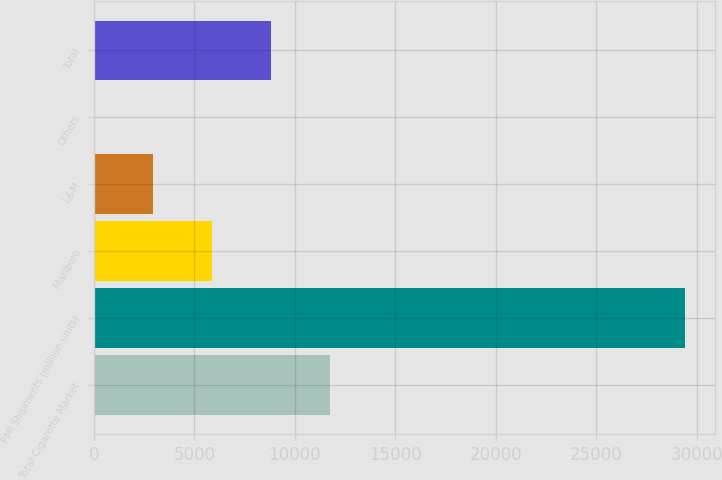Convert chart. <chart><loc_0><loc_0><loc_500><loc_500><bar_chart><fcel>Total Cigarette Market<fcel>PMI Shipments (million units)<fcel>Marlboro<fcel>L&M<fcel>Others<fcel>Total<nl><fcel>11765.2<fcel>29411<fcel>5883.32<fcel>2942.36<fcel>1.4<fcel>8824.28<nl></chart> 